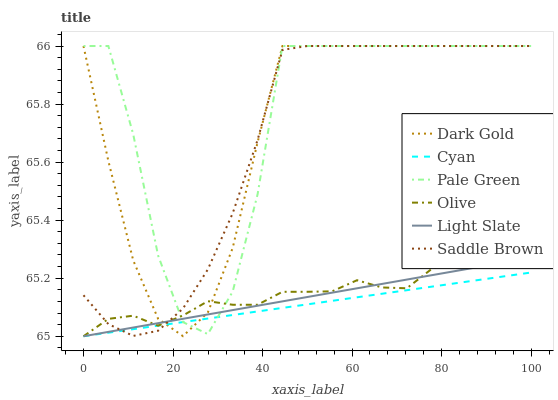Does Cyan have the minimum area under the curve?
Answer yes or no. Yes. Does Pale Green have the maximum area under the curve?
Answer yes or no. Yes. Does Light Slate have the minimum area under the curve?
Answer yes or no. No. Does Light Slate have the maximum area under the curve?
Answer yes or no. No. Is Light Slate the smoothest?
Answer yes or no. Yes. Is Pale Green the roughest?
Answer yes or no. Yes. Is Pale Green the smoothest?
Answer yes or no. No. Is Light Slate the roughest?
Answer yes or no. No. Does Pale Green have the lowest value?
Answer yes or no. No. Does Light Slate have the highest value?
Answer yes or no. No. 